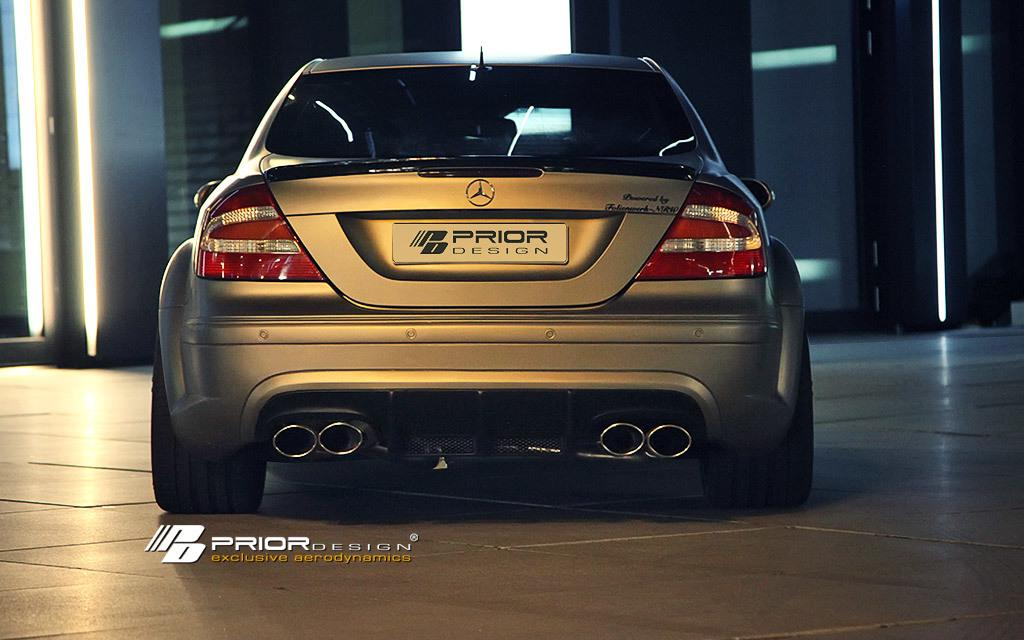What is the main subject of the image? The main subject of the image is a car. Are there any additional features in the image besides the car? Yes, there are lights on a pillar in the top left of the image. What type of writing can be seen on the car's bumper in the image? There is no writing visible on the car's bumper in the image. Is there a school visible in the image? No, there is no school present in the image. 